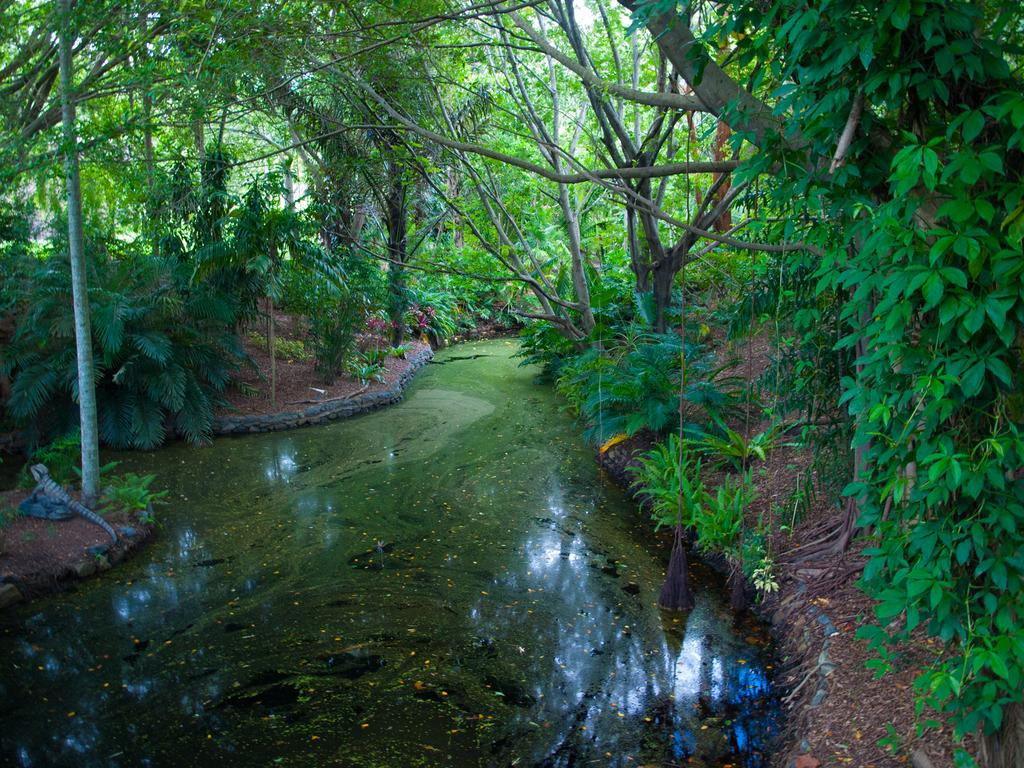What type of vegetation can be seen in the image? There are trees and plants in the image. What natural element is visible in the image? There is water visible in the image. Can you describe the reptile in the image? There is a reptile on a stone in the image. How many tents are set up near the water in the image? There are no tents present in the image. What type of bubble can be seen floating near the reptile? There are no bubbles present in the image. 